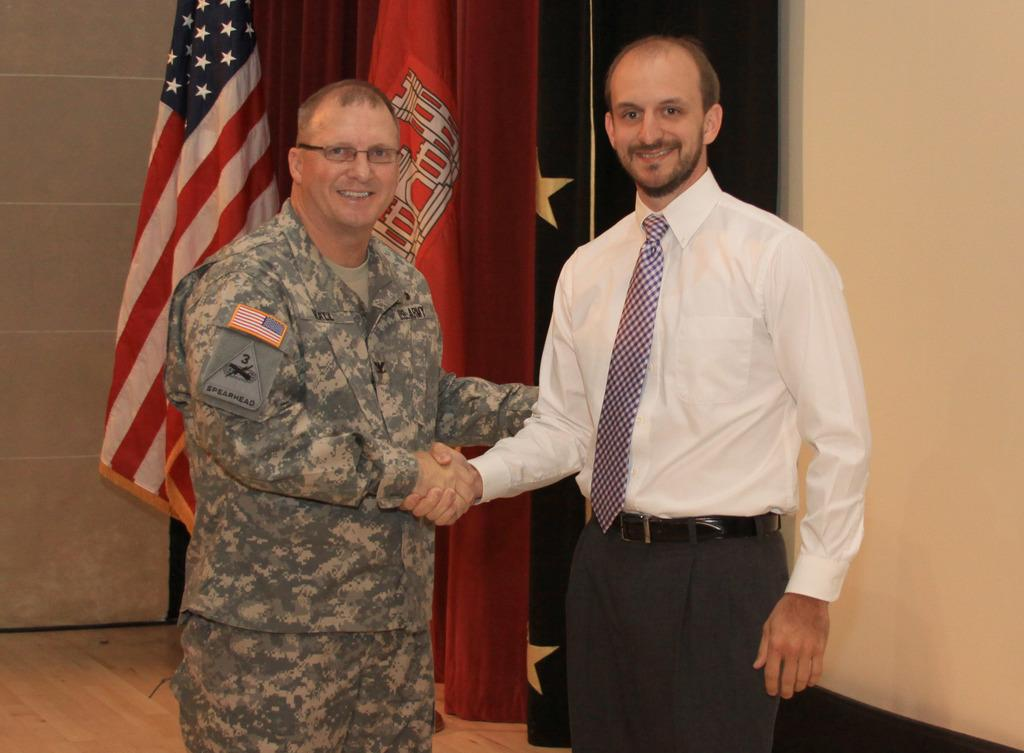Who is present in the image? There is a soldier and another man in the image. Where are the soldier and the man located in the image? The soldier and the man are in the center of the image. What can be seen in the background of the image? There are flags in the background of the image. What type of garden can be seen in the image? There is no garden present in the image. How many balloons are being held by the soldier in the image? There are no balloons present in the image. 